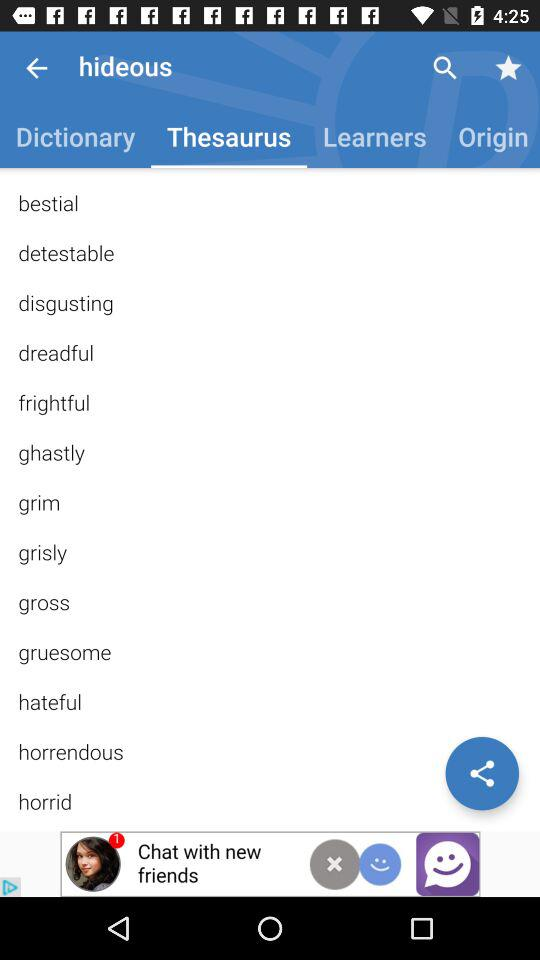Which tab is selected? The selected tab is "Thesaurus". 